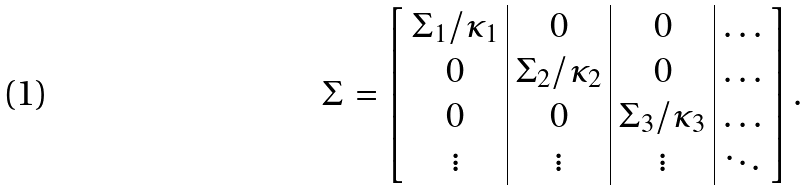Convert formula to latex. <formula><loc_0><loc_0><loc_500><loc_500>\Sigma = \left [ \begin{array} { c | c | c | c } \Sigma _ { 1 } / \kappa _ { 1 } & 0 & 0 & \dots \\ 0 & \Sigma _ { 2 } / \kappa _ { 2 } & 0 & \dots \\ 0 & 0 & \Sigma _ { 3 } / \kappa _ { 3 } & \dots \\ \vdots & \vdots & \vdots & \ddots \\ \end{array} \right ] .</formula> 